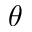<formula> <loc_0><loc_0><loc_500><loc_500>\theta</formula> 